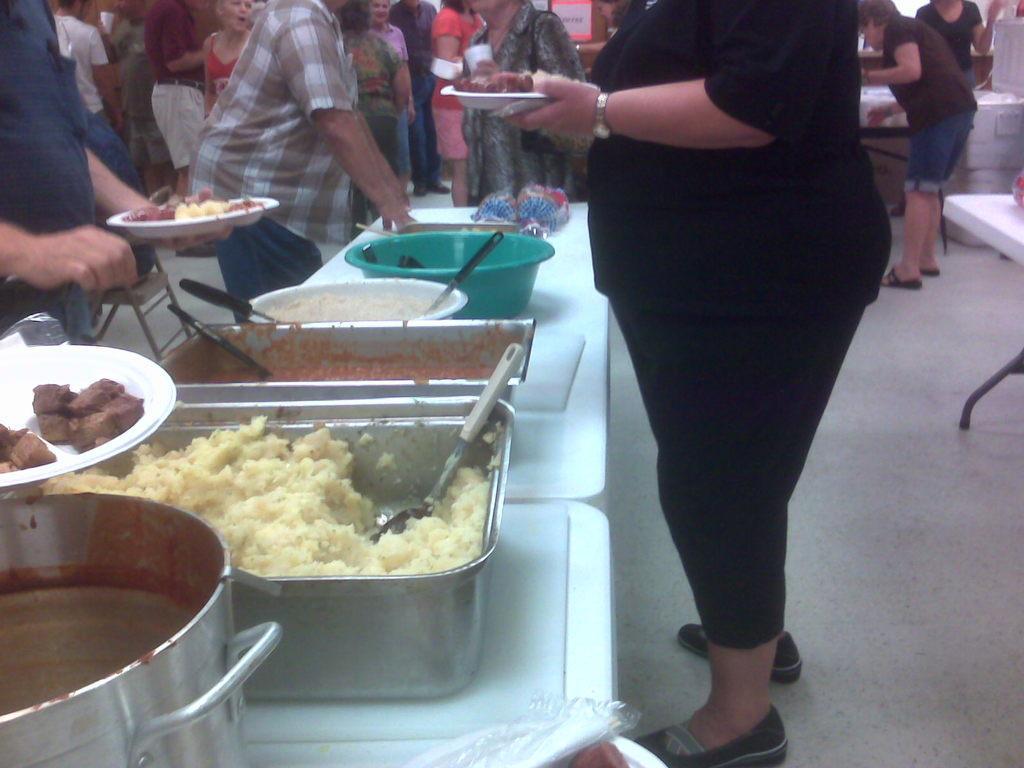How would you summarize this image in a sentence or two? It is a buffet,people are serving the food that is kept on a table. Behind the table there are few women. 